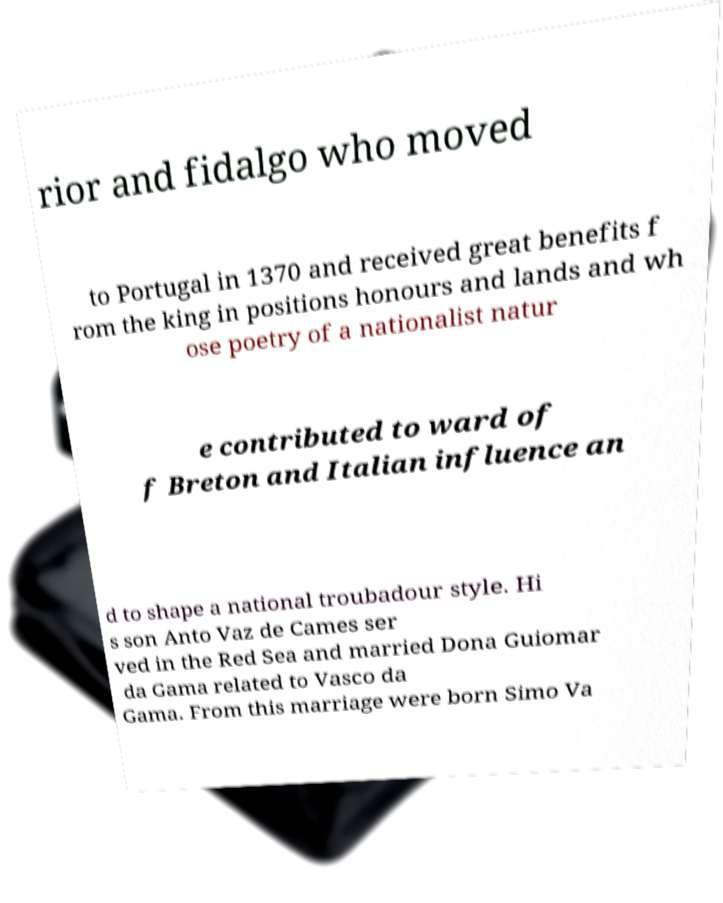There's text embedded in this image that I need extracted. Can you transcribe it verbatim? rior and fidalgo who moved to Portugal in 1370 and received great benefits f rom the king in positions honours and lands and wh ose poetry of a nationalist natur e contributed to ward of f Breton and Italian influence an d to shape a national troubadour style. Hi s son Anto Vaz de Cames ser ved in the Red Sea and married Dona Guiomar da Gama related to Vasco da Gama. From this marriage were born Simo Va 